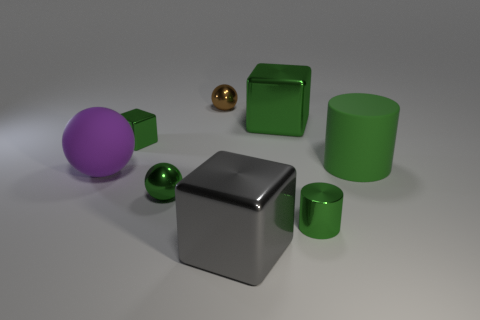There is a small object that is in front of the green metallic ball; is its shape the same as the large thing that is in front of the purple sphere?
Provide a short and direct response. No. How big is the metallic block that is both behind the tiny green metal cylinder and right of the green metallic ball?
Provide a succinct answer. Large. There is another big thing that is the same shape as the big gray thing; what color is it?
Provide a short and direct response. Green. What color is the large block on the left side of the large metallic thing that is on the right side of the big gray object?
Offer a very short reply. Gray. The small brown metal thing is what shape?
Keep it short and to the point. Sphere. What is the shape of the green shiny object that is behind the metallic cylinder and in front of the tiny shiny block?
Provide a succinct answer. Sphere. The cylinder that is made of the same material as the small green block is what color?
Your answer should be very brief. Green. There is a small green metallic thing right of the thing behind the big block that is behind the small green metallic ball; what is its shape?
Keep it short and to the point. Cylinder. What is the size of the purple thing?
Ensure brevity in your answer.  Large. What is the shape of the brown object that is made of the same material as the big gray block?
Keep it short and to the point. Sphere. 